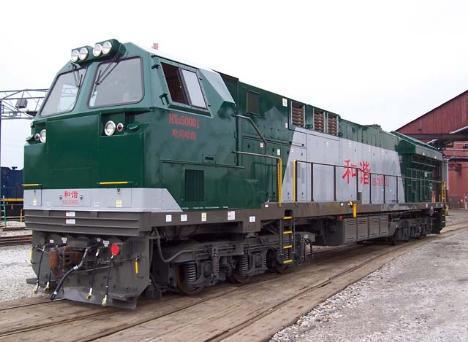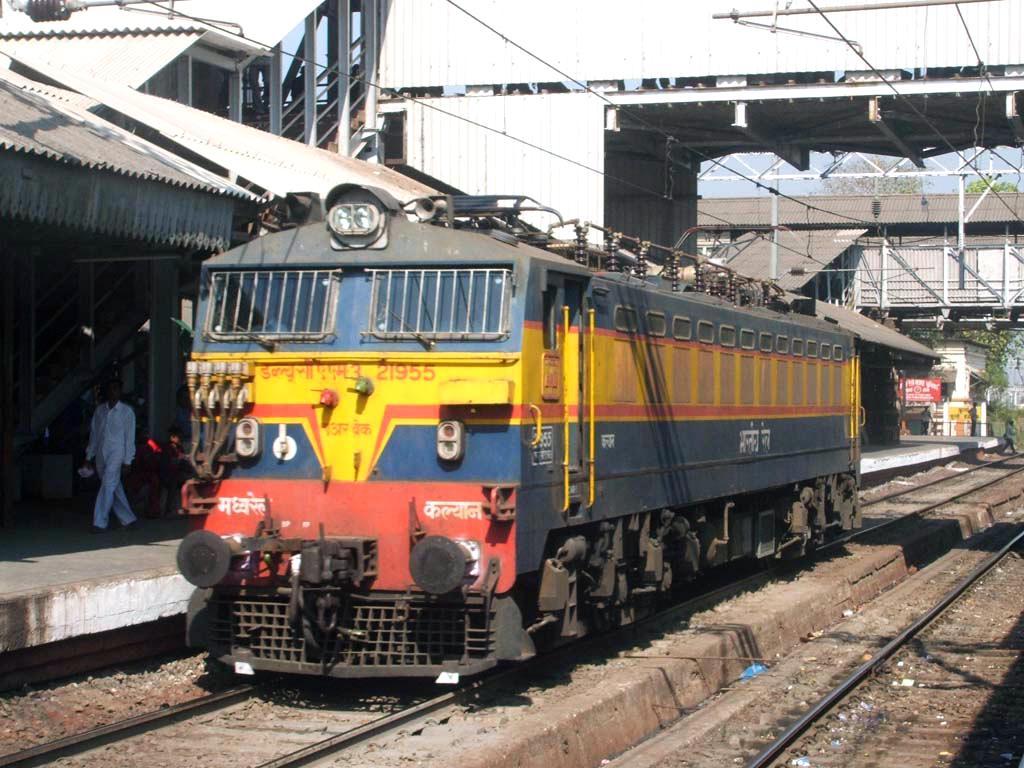The first image is the image on the left, the second image is the image on the right. Given the left and right images, does the statement "Both trains are facing left" hold true? Answer yes or no. Yes. 